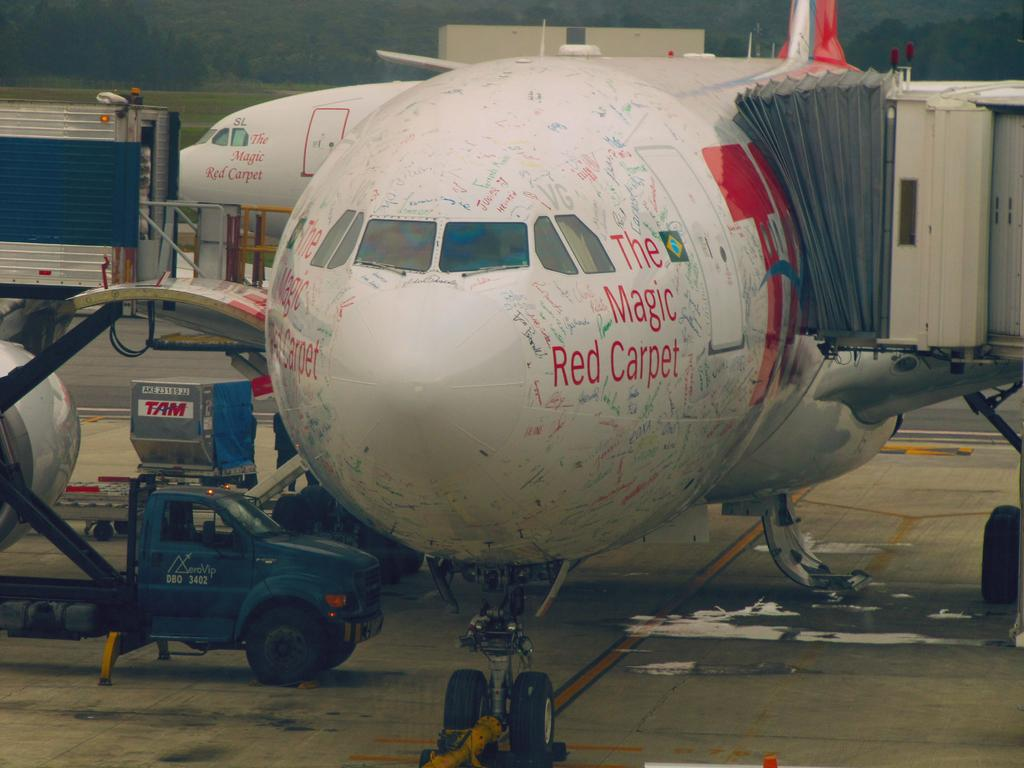Provide a one-sentence caption for the provided image. A large jet airplane with the name "The Magic carpet" on the sides is docked at the terminal ready to be loaded. 